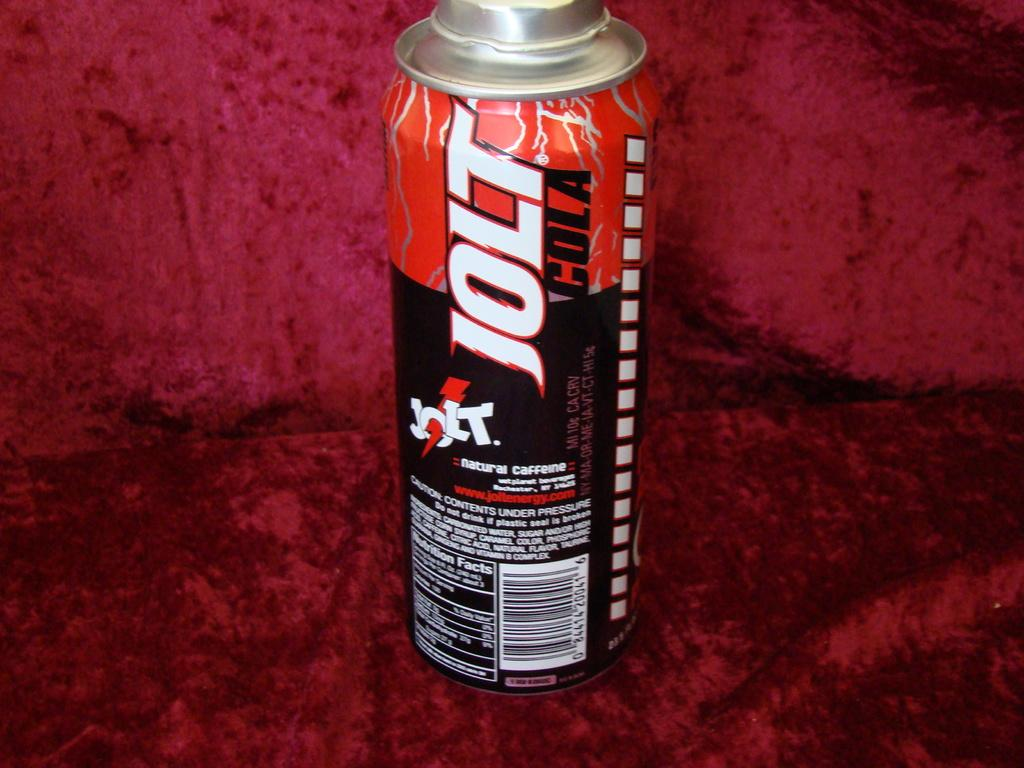Provide a one-sentence caption for the provided image. The natural caffeine drink is called Jolt Cola. 